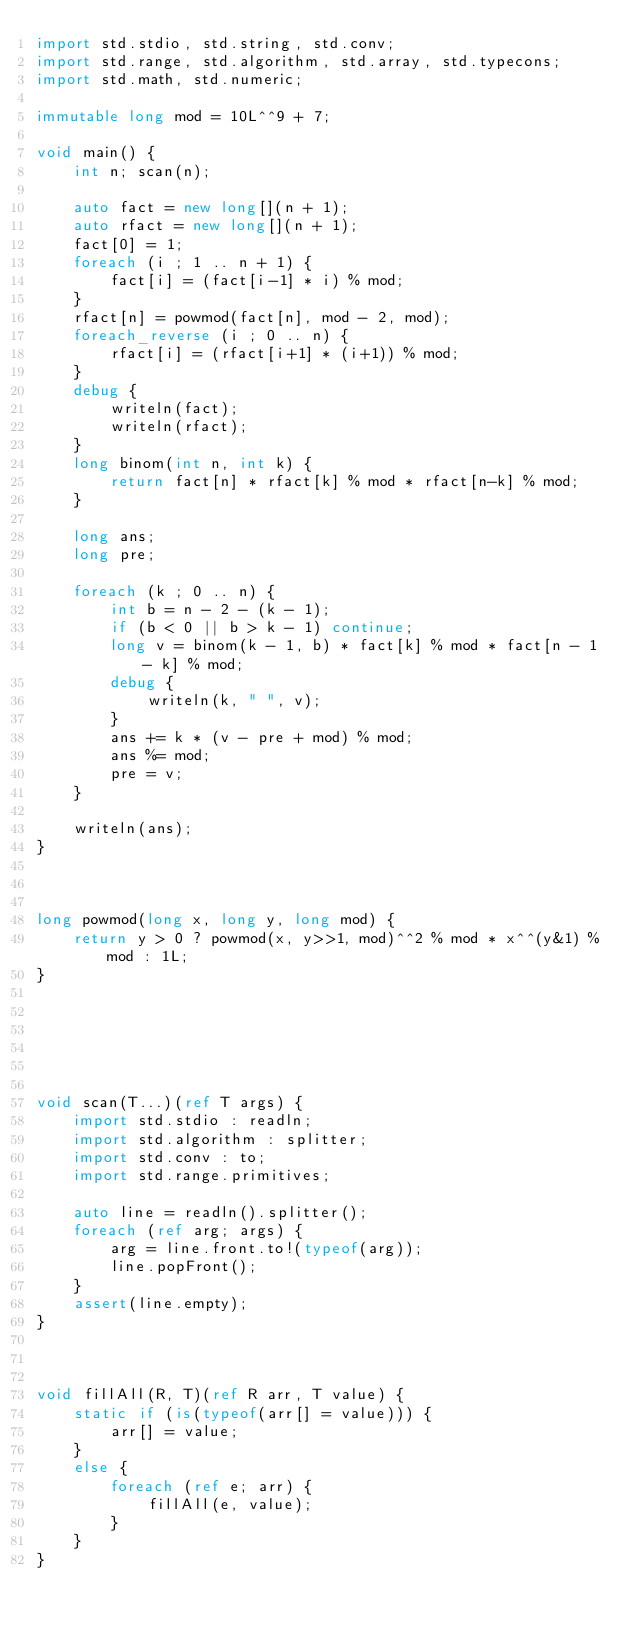Convert code to text. <code><loc_0><loc_0><loc_500><loc_500><_D_>import std.stdio, std.string, std.conv;
import std.range, std.algorithm, std.array, std.typecons;
import std.math, std.numeric;

immutable long mod = 10L^^9 + 7;

void main() {
    int n; scan(n);

    auto fact = new long[](n + 1);
    auto rfact = new long[](n + 1);
    fact[0] = 1;
    foreach (i ; 1 .. n + 1) {
        fact[i] = (fact[i-1] * i) % mod;
    }
    rfact[n] = powmod(fact[n], mod - 2, mod);
    foreach_reverse (i ; 0 .. n) {
        rfact[i] = (rfact[i+1] * (i+1)) % mod;
    }
    debug {
        writeln(fact);
        writeln(rfact);
    }
    long binom(int n, int k) {
        return fact[n] * rfact[k] % mod * rfact[n-k] % mod;
    }

    long ans;
    long pre;

    foreach (k ; 0 .. n) {
        int b = n - 2 - (k - 1);
        if (b < 0 || b > k - 1) continue;
        long v = binom(k - 1, b) * fact[k] % mod * fact[n - 1 - k] % mod;
        debug {
            writeln(k, " ", v);
        }
        ans += k * (v - pre + mod) % mod;
        ans %= mod;
        pre = v;
    }

    writeln(ans);
}



long powmod(long x, long y, long mod) {
    return y > 0 ? powmod(x, y>>1, mod)^^2 % mod * x^^(y&1) % mod : 1L;
}






void scan(T...)(ref T args) {
    import std.stdio : readln;
    import std.algorithm : splitter;
    import std.conv : to;
    import std.range.primitives;

    auto line = readln().splitter();
    foreach (ref arg; args) {
        arg = line.front.to!(typeof(arg));
        line.popFront();
    }
    assert(line.empty);
}



void fillAll(R, T)(ref R arr, T value) {
    static if (is(typeof(arr[] = value))) {
        arr[] = value;
    }
    else {
        foreach (ref e; arr) {
            fillAll(e, value);
        }
    }
}
</code> 